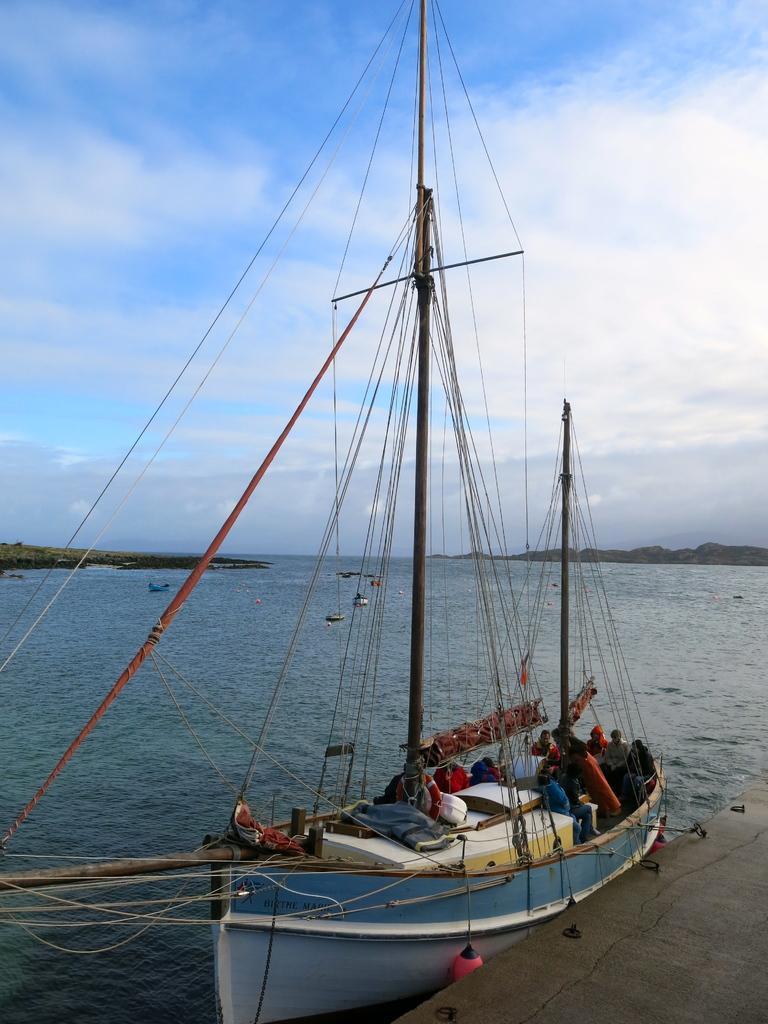Could you give a brief overview of what you see in this image? In this image we can see a boat in which we can see a few people and some objects are kept is floating on the water. Here we can see the surface, we can see ropes, hills and the blue sky with clouds in the background. 